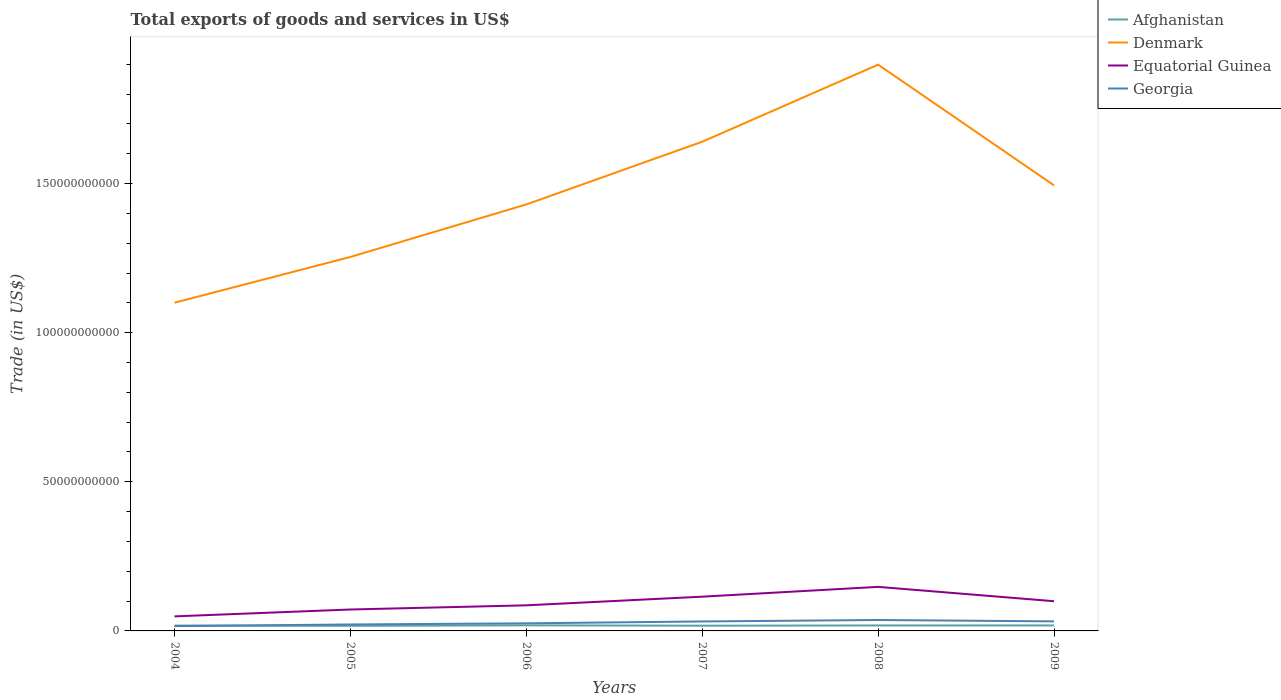Across all years, what is the maximum total exports of goods and services in Afghanistan?
Provide a short and direct response. 1.72e+09. What is the total total exports of goods and services in Afghanistan in the graph?
Make the answer very short. 3.16e+07. What is the difference between the highest and the second highest total exports of goods and services in Equatorial Guinea?
Your answer should be very brief. 9.89e+09. What is the difference between the highest and the lowest total exports of goods and services in Georgia?
Give a very brief answer. 3. How many lines are there?
Give a very brief answer. 4. How many years are there in the graph?
Provide a short and direct response. 6. Does the graph contain grids?
Ensure brevity in your answer.  No. How many legend labels are there?
Your answer should be compact. 4. What is the title of the graph?
Your answer should be very brief. Total exports of goods and services in US$. Does "Philippines" appear as one of the legend labels in the graph?
Give a very brief answer. No. What is the label or title of the X-axis?
Your response must be concise. Years. What is the label or title of the Y-axis?
Offer a terse response. Trade (in US$). What is the Trade (in US$) in Afghanistan in 2004?
Ensure brevity in your answer.  1.80e+09. What is the Trade (in US$) of Denmark in 2004?
Ensure brevity in your answer.  1.10e+11. What is the Trade (in US$) in Equatorial Guinea in 2004?
Give a very brief answer. 4.88e+09. What is the Trade (in US$) in Georgia in 2004?
Make the answer very short. 1.62e+09. What is the Trade (in US$) of Afghanistan in 2005?
Provide a short and direct response. 1.72e+09. What is the Trade (in US$) in Denmark in 2005?
Your answer should be very brief. 1.25e+11. What is the Trade (in US$) of Equatorial Guinea in 2005?
Provide a short and direct response. 7.18e+09. What is the Trade (in US$) of Georgia in 2005?
Provide a short and direct response. 2.16e+09. What is the Trade (in US$) in Afghanistan in 2006?
Offer a very short reply. 1.87e+09. What is the Trade (in US$) in Denmark in 2006?
Ensure brevity in your answer.  1.43e+11. What is the Trade (in US$) in Equatorial Guinea in 2006?
Keep it short and to the point. 8.58e+09. What is the Trade (in US$) in Georgia in 2006?
Provide a short and direct response. 2.55e+09. What is the Trade (in US$) in Afghanistan in 2007?
Your answer should be very brief. 1.75e+09. What is the Trade (in US$) of Denmark in 2007?
Provide a succinct answer. 1.64e+11. What is the Trade (in US$) of Equatorial Guinea in 2007?
Provide a succinct answer. 1.15e+1. What is the Trade (in US$) in Georgia in 2007?
Keep it short and to the point. 3.17e+09. What is the Trade (in US$) of Afghanistan in 2008?
Your answer should be compact. 1.83e+09. What is the Trade (in US$) in Denmark in 2008?
Offer a very short reply. 1.90e+11. What is the Trade (in US$) of Equatorial Guinea in 2008?
Give a very brief answer. 1.48e+1. What is the Trade (in US$) in Georgia in 2008?
Give a very brief answer. 3.66e+09. What is the Trade (in US$) of Afghanistan in 2009?
Keep it short and to the point. 1.84e+09. What is the Trade (in US$) in Denmark in 2009?
Your answer should be very brief. 1.49e+11. What is the Trade (in US$) in Equatorial Guinea in 2009?
Your answer should be compact. 9.96e+09. What is the Trade (in US$) of Georgia in 2009?
Your response must be concise. 3.20e+09. Across all years, what is the maximum Trade (in US$) of Afghanistan?
Your answer should be compact. 1.87e+09. Across all years, what is the maximum Trade (in US$) of Denmark?
Make the answer very short. 1.90e+11. Across all years, what is the maximum Trade (in US$) in Equatorial Guinea?
Your answer should be compact. 1.48e+1. Across all years, what is the maximum Trade (in US$) in Georgia?
Your answer should be very brief. 3.66e+09. Across all years, what is the minimum Trade (in US$) in Afghanistan?
Your response must be concise. 1.72e+09. Across all years, what is the minimum Trade (in US$) in Denmark?
Keep it short and to the point. 1.10e+11. Across all years, what is the minimum Trade (in US$) of Equatorial Guinea?
Provide a short and direct response. 4.88e+09. Across all years, what is the minimum Trade (in US$) of Georgia?
Your response must be concise. 1.62e+09. What is the total Trade (in US$) of Afghanistan in the graph?
Offer a terse response. 1.08e+1. What is the total Trade (in US$) of Denmark in the graph?
Provide a succinct answer. 8.82e+11. What is the total Trade (in US$) in Equatorial Guinea in the graph?
Provide a succinct answer. 5.69e+1. What is the total Trade (in US$) of Georgia in the graph?
Your answer should be very brief. 1.64e+1. What is the difference between the Trade (in US$) in Afghanistan in 2004 and that in 2005?
Provide a short and direct response. 7.78e+07. What is the difference between the Trade (in US$) of Denmark in 2004 and that in 2005?
Offer a terse response. -1.53e+1. What is the difference between the Trade (in US$) of Equatorial Guinea in 2004 and that in 2005?
Provide a short and direct response. -2.30e+09. What is the difference between the Trade (in US$) in Georgia in 2004 and that in 2005?
Make the answer very short. -5.46e+08. What is the difference between the Trade (in US$) in Afghanistan in 2004 and that in 2006?
Give a very brief answer. -7.13e+07. What is the difference between the Trade (in US$) in Denmark in 2004 and that in 2006?
Ensure brevity in your answer.  -3.29e+1. What is the difference between the Trade (in US$) in Equatorial Guinea in 2004 and that in 2006?
Offer a very short reply. -3.70e+09. What is the difference between the Trade (in US$) in Georgia in 2004 and that in 2006?
Keep it short and to the point. -9.28e+08. What is the difference between the Trade (in US$) in Afghanistan in 2004 and that in 2007?
Offer a very short reply. 4.23e+07. What is the difference between the Trade (in US$) of Denmark in 2004 and that in 2007?
Your answer should be compact. -5.40e+1. What is the difference between the Trade (in US$) in Equatorial Guinea in 2004 and that in 2007?
Your response must be concise. -6.61e+09. What is the difference between the Trade (in US$) in Georgia in 2004 and that in 2007?
Your answer should be compact. -1.56e+09. What is the difference between the Trade (in US$) in Afghanistan in 2004 and that in 2008?
Offer a terse response. -3.67e+07. What is the difference between the Trade (in US$) of Denmark in 2004 and that in 2008?
Provide a short and direct response. -7.98e+1. What is the difference between the Trade (in US$) of Equatorial Guinea in 2004 and that in 2008?
Make the answer very short. -9.89e+09. What is the difference between the Trade (in US$) in Georgia in 2004 and that in 2008?
Give a very brief answer. -2.04e+09. What is the difference between the Trade (in US$) of Afghanistan in 2004 and that in 2009?
Keep it short and to the point. -3.97e+07. What is the difference between the Trade (in US$) in Denmark in 2004 and that in 2009?
Your response must be concise. -3.93e+1. What is the difference between the Trade (in US$) of Equatorial Guinea in 2004 and that in 2009?
Provide a succinct answer. -5.08e+09. What is the difference between the Trade (in US$) of Georgia in 2004 and that in 2009?
Ensure brevity in your answer.  -1.58e+09. What is the difference between the Trade (in US$) of Afghanistan in 2005 and that in 2006?
Your answer should be very brief. -1.49e+08. What is the difference between the Trade (in US$) of Denmark in 2005 and that in 2006?
Give a very brief answer. -1.76e+1. What is the difference between the Trade (in US$) of Equatorial Guinea in 2005 and that in 2006?
Your answer should be compact. -1.40e+09. What is the difference between the Trade (in US$) of Georgia in 2005 and that in 2006?
Provide a short and direct response. -3.82e+08. What is the difference between the Trade (in US$) in Afghanistan in 2005 and that in 2007?
Give a very brief answer. -3.55e+07. What is the difference between the Trade (in US$) of Denmark in 2005 and that in 2007?
Give a very brief answer. -3.86e+1. What is the difference between the Trade (in US$) of Equatorial Guinea in 2005 and that in 2007?
Your response must be concise. -4.30e+09. What is the difference between the Trade (in US$) in Georgia in 2005 and that in 2007?
Make the answer very short. -1.01e+09. What is the difference between the Trade (in US$) in Afghanistan in 2005 and that in 2008?
Your answer should be compact. -1.15e+08. What is the difference between the Trade (in US$) in Denmark in 2005 and that in 2008?
Offer a very short reply. -6.45e+1. What is the difference between the Trade (in US$) in Equatorial Guinea in 2005 and that in 2008?
Offer a terse response. -7.59e+09. What is the difference between the Trade (in US$) of Georgia in 2005 and that in 2008?
Your answer should be compact. -1.50e+09. What is the difference between the Trade (in US$) of Afghanistan in 2005 and that in 2009?
Provide a succinct answer. -1.17e+08. What is the difference between the Trade (in US$) in Denmark in 2005 and that in 2009?
Offer a terse response. -2.40e+1. What is the difference between the Trade (in US$) of Equatorial Guinea in 2005 and that in 2009?
Give a very brief answer. -2.77e+09. What is the difference between the Trade (in US$) in Georgia in 2005 and that in 2009?
Keep it short and to the point. -1.04e+09. What is the difference between the Trade (in US$) of Afghanistan in 2006 and that in 2007?
Keep it short and to the point. 1.14e+08. What is the difference between the Trade (in US$) in Denmark in 2006 and that in 2007?
Make the answer very short. -2.10e+1. What is the difference between the Trade (in US$) in Equatorial Guinea in 2006 and that in 2007?
Ensure brevity in your answer.  -2.90e+09. What is the difference between the Trade (in US$) in Georgia in 2006 and that in 2007?
Ensure brevity in your answer.  -6.29e+08. What is the difference between the Trade (in US$) in Afghanistan in 2006 and that in 2008?
Provide a short and direct response. 3.46e+07. What is the difference between the Trade (in US$) in Denmark in 2006 and that in 2008?
Make the answer very short. -4.69e+1. What is the difference between the Trade (in US$) of Equatorial Guinea in 2006 and that in 2008?
Your response must be concise. -6.19e+09. What is the difference between the Trade (in US$) in Georgia in 2006 and that in 2008?
Your answer should be very brief. -1.12e+09. What is the difference between the Trade (in US$) of Afghanistan in 2006 and that in 2009?
Provide a short and direct response. 3.16e+07. What is the difference between the Trade (in US$) in Denmark in 2006 and that in 2009?
Provide a succinct answer. -6.39e+09. What is the difference between the Trade (in US$) in Equatorial Guinea in 2006 and that in 2009?
Ensure brevity in your answer.  -1.38e+09. What is the difference between the Trade (in US$) of Georgia in 2006 and that in 2009?
Keep it short and to the point. -6.56e+08. What is the difference between the Trade (in US$) in Afghanistan in 2007 and that in 2008?
Your response must be concise. -7.90e+07. What is the difference between the Trade (in US$) of Denmark in 2007 and that in 2008?
Provide a succinct answer. -2.58e+1. What is the difference between the Trade (in US$) in Equatorial Guinea in 2007 and that in 2008?
Offer a very short reply. -3.29e+09. What is the difference between the Trade (in US$) in Georgia in 2007 and that in 2008?
Offer a very short reply. -4.87e+08. What is the difference between the Trade (in US$) of Afghanistan in 2007 and that in 2009?
Offer a terse response. -8.20e+07. What is the difference between the Trade (in US$) of Denmark in 2007 and that in 2009?
Ensure brevity in your answer.  1.46e+1. What is the difference between the Trade (in US$) in Equatorial Guinea in 2007 and that in 2009?
Offer a terse response. 1.53e+09. What is the difference between the Trade (in US$) of Georgia in 2007 and that in 2009?
Keep it short and to the point. -2.75e+07. What is the difference between the Trade (in US$) in Afghanistan in 2008 and that in 2009?
Your answer should be very brief. -2.95e+06. What is the difference between the Trade (in US$) of Denmark in 2008 and that in 2009?
Provide a succinct answer. 4.05e+1. What is the difference between the Trade (in US$) of Equatorial Guinea in 2008 and that in 2009?
Provide a succinct answer. 4.81e+09. What is the difference between the Trade (in US$) of Georgia in 2008 and that in 2009?
Ensure brevity in your answer.  4.60e+08. What is the difference between the Trade (in US$) of Afghanistan in 2004 and the Trade (in US$) of Denmark in 2005?
Provide a succinct answer. -1.24e+11. What is the difference between the Trade (in US$) of Afghanistan in 2004 and the Trade (in US$) of Equatorial Guinea in 2005?
Provide a succinct answer. -5.39e+09. What is the difference between the Trade (in US$) in Afghanistan in 2004 and the Trade (in US$) in Georgia in 2005?
Your answer should be very brief. -3.67e+08. What is the difference between the Trade (in US$) in Denmark in 2004 and the Trade (in US$) in Equatorial Guinea in 2005?
Your answer should be compact. 1.03e+11. What is the difference between the Trade (in US$) of Denmark in 2004 and the Trade (in US$) of Georgia in 2005?
Give a very brief answer. 1.08e+11. What is the difference between the Trade (in US$) of Equatorial Guinea in 2004 and the Trade (in US$) of Georgia in 2005?
Ensure brevity in your answer.  2.72e+09. What is the difference between the Trade (in US$) of Afghanistan in 2004 and the Trade (in US$) of Denmark in 2006?
Your answer should be compact. -1.41e+11. What is the difference between the Trade (in US$) in Afghanistan in 2004 and the Trade (in US$) in Equatorial Guinea in 2006?
Make the answer very short. -6.78e+09. What is the difference between the Trade (in US$) of Afghanistan in 2004 and the Trade (in US$) of Georgia in 2006?
Provide a short and direct response. -7.49e+08. What is the difference between the Trade (in US$) of Denmark in 2004 and the Trade (in US$) of Equatorial Guinea in 2006?
Provide a short and direct response. 1.01e+11. What is the difference between the Trade (in US$) in Denmark in 2004 and the Trade (in US$) in Georgia in 2006?
Your answer should be compact. 1.08e+11. What is the difference between the Trade (in US$) in Equatorial Guinea in 2004 and the Trade (in US$) in Georgia in 2006?
Your answer should be very brief. 2.33e+09. What is the difference between the Trade (in US$) in Afghanistan in 2004 and the Trade (in US$) in Denmark in 2007?
Offer a terse response. -1.62e+11. What is the difference between the Trade (in US$) of Afghanistan in 2004 and the Trade (in US$) of Equatorial Guinea in 2007?
Keep it short and to the point. -9.69e+09. What is the difference between the Trade (in US$) in Afghanistan in 2004 and the Trade (in US$) in Georgia in 2007?
Offer a terse response. -1.38e+09. What is the difference between the Trade (in US$) in Denmark in 2004 and the Trade (in US$) in Equatorial Guinea in 2007?
Provide a succinct answer. 9.86e+1. What is the difference between the Trade (in US$) of Denmark in 2004 and the Trade (in US$) of Georgia in 2007?
Offer a terse response. 1.07e+11. What is the difference between the Trade (in US$) of Equatorial Guinea in 2004 and the Trade (in US$) of Georgia in 2007?
Ensure brevity in your answer.  1.70e+09. What is the difference between the Trade (in US$) in Afghanistan in 2004 and the Trade (in US$) in Denmark in 2008?
Your answer should be very brief. -1.88e+11. What is the difference between the Trade (in US$) in Afghanistan in 2004 and the Trade (in US$) in Equatorial Guinea in 2008?
Your answer should be very brief. -1.30e+1. What is the difference between the Trade (in US$) in Afghanistan in 2004 and the Trade (in US$) in Georgia in 2008?
Offer a terse response. -1.87e+09. What is the difference between the Trade (in US$) of Denmark in 2004 and the Trade (in US$) of Equatorial Guinea in 2008?
Ensure brevity in your answer.  9.53e+1. What is the difference between the Trade (in US$) in Denmark in 2004 and the Trade (in US$) in Georgia in 2008?
Keep it short and to the point. 1.06e+11. What is the difference between the Trade (in US$) of Equatorial Guinea in 2004 and the Trade (in US$) of Georgia in 2008?
Your answer should be very brief. 1.22e+09. What is the difference between the Trade (in US$) in Afghanistan in 2004 and the Trade (in US$) in Denmark in 2009?
Ensure brevity in your answer.  -1.48e+11. What is the difference between the Trade (in US$) in Afghanistan in 2004 and the Trade (in US$) in Equatorial Guinea in 2009?
Make the answer very short. -8.16e+09. What is the difference between the Trade (in US$) in Afghanistan in 2004 and the Trade (in US$) in Georgia in 2009?
Make the answer very short. -1.41e+09. What is the difference between the Trade (in US$) of Denmark in 2004 and the Trade (in US$) of Equatorial Guinea in 2009?
Offer a terse response. 1.00e+11. What is the difference between the Trade (in US$) in Denmark in 2004 and the Trade (in US$) in Georgia in 2009?
Your answer should be compact. 1.07e+11. What is the difference between the Trade (in US$) of Equatorial Guinea in 2004 and the Trade (in US$) of Georgia in 2009?
Ensure brevity in your answer.  1.68e+09. What is the difference between the Trade (in US$) of Afghanistan in 2005 and the Trade (in US$) of Denmark in 2006?
Provide a short and direct response. -1.41e+11. What is the difference between the Trade (in US$) in Afghanistan in 2005 and the Trade (in US$) in Equatorial Guinea in 2006?
Offer a very short reply. -6.86e+09. What is the difference between the Trade (in US$) in Afghanistan in 2005 and the Trade (in US$) in Georgia in 2006?
Give a very brief answer. -8.26e+08. What is the difference between the Trade (in US$) in Denmark in 2005 and the Trade (in US$) in Equatorial Guinea in 2006?
Offer a terse response. 1.17e+11. What is the difference between the Trade (in US$) in Denmark in 2005 and the Trade (in US$) in Georgia in 2006?
Give a very brief answer. 1.23e+11. What is the difference between the Trade (in US$) in Equatorial Guinea in 2005 and the Trade (in US$) in Georgia in 2006?
Provide a succinct answer. 4.64e+09. What is the difference between the Trade (in US$) in Afghanistan in 2005 and the Trade (in US$) in Denmark in 2007?
Provide a succinct answer. -1.62e+11. What is the difference between the Trade (in US$) of Afghanistan in 2005 and the Trade (in US$) of Equatorial Guinea in 2007?
Offer a terse response. -9.77e+09. What is the difference between the Trade (in US$) in Afghanistan in 2005 and the Trade (in US$) in Georgia in 2007?
Give a very brief answer. -1.46e+09. What is the difference between the Trade (in US$) in Denmark in 2005 and the Trade (in US$) in Equatorial Guinea in 2007?
Your answer should be compact. 1.14e+11. What is the difference between the Trade (in US$) in Denmark in 2005 and the Trade (in US$) in Georgia in 2007?
Offer a very short reply. 1.22e+11. What is the difference between the Trade (in US$) of Equatorial Guinea in 2005 and the Trade (in US$) of Georgia in 2007?
Provide a succinct answer. 4.01e+09. What is the difference between the Trade (in US$) of Afghanistan in 2005 and the Trade (in US$) of Denmark in 2008?
Ensure brevity in your answer.  -1.88e+11. What is the difference between the Trade (in US$) in Afghanistan in 2005 and the Trade (in US$) in Equatorial Guinea in 2008?
Your response must be concise. -1.31e+1. What is the difference between the Trade (in US$) of Afghanistan in 2005 and the Trade (in US$) of Georgia in 2008?
Keep it short and to the point. -1.94e+09. What is the difference between the Trade (in US$) of Denmark in 2005 and the Trade (in US$) of Equatorial Guinea in 2008?
Your answer should be very brief. 1.11e+11. What is the difference between the Trade (in US$) of Denmark in 2005 and the Trade (in US$) of Georgia in 2008?
Offer a very short reply. 1.22e+11. What is the difference between the Trade (in US$) in Equatorial Guinea in 2005 and the Trade (in US$) in Georgia in 2008?
Your answer should be very brief. 3.52e+09. What is the difference between the Trade (in US$) of Afghanistan in 2005 and the Trade (in US$) of Denmark in 2009?
Offer a very short reply. -1.48e+11. What is the difference between the Trade (in US$) in Afghanistan in 2005 and the Trade (in US$) in Equatorial Guinea in 2009?
Offer a terse response. -8.24e+09. What is the difference between the Trade (in US$) in Afghanistan in 2005 and the Trade (in US$) in Georgia in 2009?
Offer a very short reply. -1.48e+09. What is the difference between the Trade (in US$) in Denmark in 2005 and the Trade (in US$) in Equatorial Guinea in 2009?
Make the answer very short. 1.15e+11. What is the difference between the Trade (in US$) in Denmark in 2005 and the Trade (in US$) in Georgia in 2009?
Provide a succinct answer. 1.22e+11. What is the difference between the Trade (in US$) of Equatorial Guinea in 2005 and the Trade (in US$) of Georgia in 2009?
Offer a very short reply. 3.98e+09. What is the difference between the Trade (in US$) in Afghanistan in 2006 and the Trade (in US$) in Denmark in 2007?
Ensure brevity in your answer.  -1.62e+11. What is the difference between the Trade (in US$) in Afghanistan in 2006 and the Trade (in US$) in Equatorial Guinea in 2007?
Your response must be concise. -9.62e+09. What is the difference between the Trade (in US$) of Afghanistan in 2006 and the Trade (in US$) of Georgia in 2007?
Keep it short and to the point. -1.31e+09. What is the difference between the Trade (in US$) in Denmark in 2006 and the Trade (in US$) in Equatorial Guinea in 2007?
Offer a terse response. 1.32e+11. What is the difference between the Trade (in US$) of Denmark in 2006 and the Trade (in US$) of Georgia in 2007?
Your response must be concise. 1.40e+11. What is the difference between the Trade (in US$) in Equatorial Guinea in 2006 and the Trade (in US$) in Georgia in 2007?
Keep it short and to the point. 5.41e+09. What is the difference between the Trade (in US$) in Afghanistan in 2006 and the Trade (in US$) in Denmark in 2008?
Your response must be concise. -1.88e+11. What is the difference between the Trade (in US$) in Afghanistan in 2006 and the Trade (in US$) in Equatorial Guinea in 2008?
Provide a short and direct response. -1.29e+1. What is the difference between the Trade (in US$) of Afghanistan in 2006 and the Trade (in US$) of Georgia in 2008?
Your answer should be very brief. -1.79e+09. What is the difference between the Trade (in US$) of Denmark in 2006 and the Trade (in US$) of Equatorial Guinea in 2008?
Your answer should be very brief. 1.28e+11. What is the difference between the Trade (in US$) of Denmark in 2006 and the Trade (in US$) of Georgia in 2008?
Your answer should be compact. 1.39e+11. What is the difference between the Trade (in US$) of Equatorial Guinea in 2006 and the Trade (in US$) of Georgia in 2008?
Provide a succinct answer. 4.92e+09. What is the difference between the Trade (in US$) of Afghanistan in 2006 and the Trade (in US$) of Denmark in 2009?
Make the answer very short. -1.48e+11. What is the difference between the Trade (in US$) of Afghanistan in 2006 and the Trade (in US$) of Equatorial Guinea in 2009?
Ensure brevity in your answer.  -8.09e+09. What is the difference between the Trade (in US$) in Afghanistan in 2006 and the Trade (in US$) in Georgia in 2009?
Provide a short and direct response. -1.33e+09. What is the difference between the Trade (in US$) in Denmark in 2006 and the Trade (in US$) in Equatorial Guinea in 2009?
Your answer should be compact. 1.33e+11. What is the difference between the Trade (in US$) of Denmark in 2006 and the Trade (in US$) of Georgia in 2009?
Provide a succinct answer. 1.40e+11. What is the difference between the Trade (in US$) in Equatorial Guinea in 2006 and the Trade (in US$) in Georgia in 2009?
Your answer should be very brief. 5.38e+09. What is the difference between the Trade (in US$) of Afghanistan in 2007 and the Trade (in US$) of Denmark in 2008?
Offer a terse response. -1.88e+11. What is the difference between the Trade (in US$) in Afghanistan in 2007 and the Trade (in US$) in Equatorial Guinea in 2008?
Provide a succinct answer. -1.30e+1. What is the difference between the Trade (in US$) of Afghanistan in 2007 and the Trade (in US$) of Georgia in 2008?
Offer a terse response. -1.91e+09. What is the difference between the Trade (in US$) of Denmark in 2007 and the Trade (in US$) of Equatorial Guinea in 2008?
Your answer should be compact. 1.49e+11. What is the difference between the Trade (in US$) in Denmark in 2007 and the Trade (in US$) in Georgia in 2008?
Provide a short and direct response. 1.60e+11. What is the difference between the Trade (in US$) in Equatorial Guinea in 2007 and the Trade (in US$) in Georgia in 2008?
Provide a short and direct response. 7.82e+09. What is the difference between the Trade (in US$) of Afghanistan in 2007 and the Trade (in US$) of Denmark in 2009?
Your answer should be compact. -1.48e+11. What is the difference between the Trade (in US$) of Afghanistan in 2007 and the Trade (in US$) of Equatorial Guinea in 2009?
Offer a terse response. -8.20e+09. What is the difference between the Trade (in US$) in Afghanistan in 2007 and the Trade (in US$) in Georgia in 2009?
Ensure brevity in your answer.  -1.45e+09. What is the difference between the Trade (in US$) in Denmark in 2007 and the Trade (in US$) in Equatorial Guinea in 2009?
Provide a succinct answer. 1.54e+11. What is the difference between the Trade (in US$) of Denmark in 2007 and the Trade (in US$) of Georgia in 2009?
Provide a succinct answer. 1.61e+11. What is the difference between the Trade (in US$) of Equatorial Guinea in 2007 and the Trade (in US$) of Georgia in 2009?
Make the answer very short. 8.28e+09. What is the difference between the Trade (in US$) of Afghanistan in 2008 and the Trade (in US$) of Denmark in 2009?
Offer a very short reply. -1.48e+11. What is the difference between the Trade (in US$) in Afghanistan in 2008 and the Trade (in US$) in Equatorial Guinea in 2009?
Make the answer very short. -8.12e+09. What is the difference between the Trade (in US$) of Afghanistan in 2008 and the Trade (in US$) of Georgia in 2009?
Offer a very short reply. -1.37e+09. What is the difference between the Trade (in US$) in Denmark in 2008 and the Trade (in US$) in Equatorial Guinea in 2009?
Provide a short and direct response. 1.80e+11. What is the difference between the Trade (in US$) of Denmark in 2008 and the Trade (in US$) of Georgia in 2009?
Your response must be concise. 1.87e+11. What is the difference between the Trade (in US$) of Equatorial Guinea in 2008 and the Trade (in US$) of Georgia in 2009?
Provide a short and direct response. 1.16e+1. What is the average Trade (in US$) in Afghanistan per year?
Provide a short and direct response. 1.80e+09. What is the average Trade (in US$) in Denmark per year?
Your response must be concise. 1.47e+11. What is the average Trade (in US$) of Equatorial Guinea per year?
Your answer should be very brief. 9.48e+09. What is the average Trade (in US$) of Georgia per year?
Your answer should be compact. 2.73e+09. In the year 2004, what is the difference between the Trade (in US$) of Afghanistan and Trade (in US$) of Denmark?
Make the answer very short. -1.08e+11. In the year 2004, what is the difference between the Trade (in US$) in Afghanistan and Trade (in US$) in Equatorial Guinea?
Ensure brevity in your answer.  -3.08e+09. In the year 2004, what is the difference between the Trade (in US$) in Afghanistan and Trade (in US$) in Georgia?
Offer a terse response. 1.80e+08. In the year 2004, what is the difference between the Trade (in US$) of Denmark and Trade (in US$) of Equatorial Guinea?
Provide a short and direct response. 1.05e+11. In the year 2004, what is the difference between the Trade (in US$) in Denmark and Trade (in US$) in Georgia?
Offer a very short reply. 1.08e+11. In the year 2004, what is the difference between the Trade (in US$) of Equatorial Guinea and Trade (in US$) of Georgia?
Offer a very short reply. 3.26e+09. In the year 2005, what is the difference between the Trade (in US$) of Afghanistan and Trade (in US$) of Denmark?
Give a very brief answer. -1.24e+11. In the year 2005, what is the difference between the Trade (in US$) of Afghanistan and Trade (in US$) of Equatorial Guinea?
Provide a succinct answer. -5.46e+09. In the year 2005, what is the difference between the Trade (in US$) in Afghanistan and Trade (in US$) in Georgia?
Your answer should be compact. -4.45e+08. In the year 2005, what is the difference between the Trade (in US$) of Denmark and Trade (in US$) of Equatorial Guinea?
Give a very brief answer. 1.18e+11. In the year 2005, what is the difference between the Trade (in US$) of Denmark and Trade (in US$) of Georgia?
Offer a terse response. 1.23e+11. In the year 2005, what is the difference between the Trade (in US$) of Equatorial Guinea and Trade (in US$) of Georgia?
Your answer should be very brief. 5.02e+09. In the year 2006, what is the difference between the Trade (in US$) of Afghanistan and Trade (in US$) of Denmark?
Give a very brief answer. -1.41e+11. In the year 2006, what is the difference between the Trade (in US$) of Afghanistan and Trade (in US$) of Equatorial Guinea?
Your answer should be very brief. -6.71e+09. In the year 2006, what is the difference between the Trade (in US$) in Afghanistan and Trade (in US$) in Georgia?
Give a very brief answer. -6.77e+08. In the year 2006, what is the difference between the Trade (in US$) of Denmark and Trade (in US$) of Equatorial Guinea?
Keep it short and to the point. 1.34e+11. In the year 2006, what is the difference between the Trade (in US$) in Denmark and Trade (in US$) in Georgia?
Offer a very short reply. 1.40e+11. In the year 2006, what is the difference between the Trade (in US$) in Equatorial Guinea and Trade (in US$) in Georgia?
Offer a very short reply. 6.04e+09. In the year 2007, what is the difference between the Trade (in US$) in Afghanistan and Trade (in US$) in Denmark?
Offer a very short reply. -1.62e+11. In the year 2007, what is the difference between the Trade (in US$) of Afghanistan and Trade (in US$) of Equatorial Guinea?
Ensure brevity in your answer.  -9.73e+09. In the year 2007, what is the difference between the Trade (in US$) of Afghanistan and Trade (in US$) of Georgia?
Give a very brief answer. -1.42e+09. In the year 2007, what is the difference between the Trade (in US$) of Denmark and Trade (in US$) of Equatorial Guinea?
Provide a short and direct response. 1.53e+11. In the year 2007, what is the difference between the Trade (in US$) in Denmark and Trade (in US$) in Georgia?
Keep it short and to the point. 1.61e+11. In the year 2007, what is the difference between the Trade (in US$) in Equatorial Guinea and Trade (in US$) in Georgia?
Give a very brief answer. 8.31e+09. In the year 2008, what is the difference between the Trade (in US$) of Afghanistan and Trade (in US$) of Denmark?
Your response must be concise. -1.88e+11. In the year 2008, what is the difference between the Trade (in US$) in Afghanistan and Trade (in US$) in Equatorial Guinea?
Your answer should be very brief. -1.29e+1. In the year 2008, what is the difference between the Trade (in US$) of Afghanistan and Trade (in US$) of Georgia?
Provide a succinct answer. -1.83e+09. In the year 2008, what is the difference between the Trade (in US$) of Denmark and Trade (in US$) of Equatorial Guinea?
Your answer should be very brief. 1.75e+11. In the year 2008, what is the difference between the Trade (in US$) of Denmark and Trade (in US$) of Georgia?
Your answer should be compact. 1.86e+11. In the year 2008, what is the difference between the Trade (in US$) in Equatorial Guinea and Trade (in US$) in Georgia?
Give a very brief answer. 1.11e+1. In the year 2009, what is the difference between the Trade (in US$) of Afghanistan and Trade (in US$) of Denmark?
Provide a succinct answer. -1.48e+11. In the year 2009, what is the difference between the Trade (in US$) of Afghanistan and Trade (in US$) of Equatorial Guinea?
Your response must be concise. -8.12e+09. In the year 2009, what is the difference between the Trade (in US$) in Afghanistan and Trade (in US$) in Georgia?
Your answer should be very brief. -1.37e+09. In the year 2009, what is the difference between the Trade (in US$) of Denmark and Trade (in US$) of Equatorial Guinea?
Give a very brief answer. 1.39e+11. In the year 2009, what is the difference between the Trade (in US$) of Denmark and Trade (in US$) of Georgia?
Make the answer very short. 1.46e+11. In the year 2009, what is the difference between the Trade (in US$) in Equatorial Guinea and Trade (in US$) in Georgia?
Offer a terse response. 6.76e+09. What is the ratio of the Trade (in US$) of Afghanistan in 2004 to that in 2005?
Provide a succinct answer. 1.05. What is the ratio of the Trade (in US$) in Denmark in 2004 to that in 2005?
Offer a very short reply. 0.88. What is the ratio of the Trade (in US$) of Equatorial Guinea in 2004 to that in 2005?
Give a very brief answer. 0.68. What is the ratio of the Trade (in US$) in Georgia in 2004 to that in 2005?
Your response must be concise. 0.75. What is the ratio of the Trade (in US$) of Afghanistan in 2004 to that in 2006?
Offer a terse response. 0.96. What is the ratio of the Trade (in US$) of Denmark in 2004 to that in 2006?
Make the answer very short. 0.77. What is the ratio of the Trade (in US$) in Equatorial Guinea in 2004 to that in 2006?
Ensure brevity in your answer.  0.57. What is the ratio of the Trade (in US$) of Georgia in 2004 to that in 2006?
Your answer should be very brief. 0.64. What is the ratio of the Trade (in US$) of Afghanistan in 2004 to that in 2007?
Keep it short and to the point. 1.02. What is the ratio of the Trade (in US$) of Denmark in 2004 to that in 2007?
Make the answer very short. 0.67. What is the ratio of the Trade (in US$) of Equatorial Guinea in 2004 to that in 2007?
Keep it short and to the point. 0.42. What is the ratio of the Trade (in US$) in Georgia in 2004 to that in 2007?
Keep it short and to the point. 0.51. What is the ratio of the Trade (in US$) in Denmark in 2004 to that in 2008?
Your answer should be very brief. 0.58. What is the ratio of the Trade (in US$) in Equatorial Guinea in 2004 to that in 2008?
Your answer should be very brief. 0.33. What is the ratio of the Trade (in US$) in Georgia in 2004 to that in 2008?
Your answer should be very brief. 0.44. What is the ratio of the Trade (in US$) of Afghanistan in 2004 to that in 2009?
Your response must be concise. 0.98. What is the ratio of the Trade (in US$) of Denmark in 2004 to that in 2009?
Offer a very short reply. 0.74. What is the ratio of the Trade (in US$) of Equatorial Guinea in 2004 to that in 2009?
Provide a succinct answer. 0.49. What is the ratio of the Trade (in US$) of Georgia in 2004 to that in 2009?
Your answer should be very brief. 0.51. What is the ratio of the Trade (in US$) of Afghanistan in 2005 to that in 2006?
Provide a short and direct response. 0.92. What is the ratio of the Trade (in US$) of Denmark in 2005 to that in 2006?
Provide a short and direct response. 0.88. What is the ratio of the Trade (in US$) of Equatorial Guinea in 2005 to that in 2006?
Your answer should be very brief. 0.84. What is the ratio of the Trade (in US$) of Georgia in 2005 to that in 2006?
Keep it short and to the point. 0.85. What is the ratio of the Trade (in US$) of Afghanistan in 2005 to that in 2007?
Provide a short and direct response. 0.98. What is the ratio of the Trade (in US$) of Denmark in 2005 to that in 2007?
Provide a short and direct response. 0.76. What is the ratio of the Trade (in US$) in Equatorial Guinea in 2005 to that in 2007?
Provide a short and direct response. 0.63. What is the ratio of the Trade (in US$) in Georgia in 2005 to that in 2007?
Your answer should be very brief. 0.68. What is the ratio of the Trade (in US$) of Afghanistan in 2005 to that in 2008?
Make the answer very short. 0.94. What is the ratio of the Trade (in US$) in Denmark in 2005 to that in 2008?
Provide a short and direct response. 0.66. What is the ratio of the Trade (in US$) of Equatorial Guinea in 2005 to that in 2008?
Ensure brevity in your answer.  0.49. What is the ratio of the Trade (in US$) of Georgia in 2005 to that in 2008?
Offer a very short reply. 0.59. What is the ratio of the Trade (in US$) of Afghanistan in 2005 to that in 2009?
Your response must be concise. 0.94. What is the ratio of the Trade (in US$) of Denmark in 2005 to that in 2009?
Your answer should be compact. 0.84. What is the ratio of the Trade (in US$) in Equatorial Guinea in 2005 to that in 2009?
Keep it short and to the point. 0.72. What is the ratio of the Trade (in US$) in Georgia in 2005 to that in 2009?
Provide a succinct answer. 0.68. What is the ratio of the Trade (in US$) of Afghanistan in 2006 to that in 2007?
Give a very brief answer. 1.06. What is the ratio of the Trade (in US$) in Denmark in 2006 to that in 2007?
Offer a terse response. 0.87. What is the ratio of the Trade (in US$) in Equatorial Guinea in 2006 to that in 2007?
Offer a very short reply. 0.75. What is the ratio of the Trade (in US$) of Georgia in 2006 to that in 2007?
Make the answer very short. 0.8. What is the ratio of the Trade (in US$) in Afghanistan in 2006 to that in 2008?
Offer a terse response. 1.02. What is the ratio of the Trade (in US$) of Denmark in 2006 to that in 2008?
Provide a succinct answer. 0.75. What is the ratio of the Trade (in US$) of Equatorial Guinea in 2006 to that in 2008?
Your answer should be compact. 0.58. What is the ratio of the Trade (in US$) in Georgia in 2006 to that in 2008?
Offer a terse response. 0.7. What is the ratio of the Trade (in US$) in Afghanistan in 2006 to that in 2009?
Ensure brevity in your answer.  1.02. What is the ratio of the Trade (in US$) of Denmark in 2006 to that in 2009?
Your answer should be compact. 0.96. What is the ratio of the Trade (in US$) in Equatorial Guinea in 2006 to that in 2009?
Provide a succinct answer. 0.86. What is the ratio of the Trade (in US$) of Georgia in 2006 to that in 2009?
Ensure brevity in your answer.  0.8. What is the ratio of the Trade (in US$) of Afghanistan in 2007 to that in 2008?
Your answer should be compact. 0.96. What is the ratio of the Trade (in US$) in Denmark in 2007 to that in 2008?
Ensure brevity in your answer.  0.86. What is the ratio of the Trade (in US$) of Equatorial Guinea in 2007 to that in 2008?
Keep it short and to the point. 0.78. What is the ratio of the Trade (in US$) in Georgia in 2007 to that in 2008?
Provide a succinct answer. 0.87. What is the ratio of the Trade (in US$) in Afghanistan in 2007 to that in 2009?
Keep it short and to the point. 0.96. What is the ratio of the Trade (in US$) in Denmark in 2007 to that in 2009?
Ensure brevity in your answer.  1.1. What is the ratio of the Trade (in US$) in Equatorial Guinea in 2007 to that in 2009?
Offer a very short reply. 1.15. What is the ratio of the Trade (in US$) in Denmark in 2008 to that in 2009?
Ensure brevity in your answer.  1.27. What is the ratio of the Trade (in US$) of Equatorial Guinea in 2008 to that in 2009?
Offer a terse response. 1.48. What is the ratio of the Trade (in US$) in Georgia in 2008 to that in 2009?
Offer a terse response. 1.14. What is the difference between the highest and the second highest Trade (in US$) in Afghanistan?
Your answer should be compact. 3.16e+07. What is the difference between the highest and the second highest Trade (in US$) in Denmark?
Make the answer very short. 2.58e+1. What is the difference between the highest and the second highest Trade (in US$) of Equatorial Guinea?
Your answer should be compact. 3.29e+09. What is the difference between the highest and the second highest Trade (in US$) of Georgia?
Offer a very short reply. 4.60e+08. What is the difference between the highest and the lowest Trade (in US$) of Afghanistan?
Provide a succinct answer. 1.49e+08. What is the difference between the highest and the lowest Trade (in US$) of Denmark?
Make the answer very short. 7.98e+1. What is the difference between the highest and the lowest Trade (in US$) in Equatorial Guinea?
Offer a terse response. 9.89e+09. What is the difference between the highest and the lowest Trade (in US$) of Georgia?
Your response must be concise. 2.04e+09. 